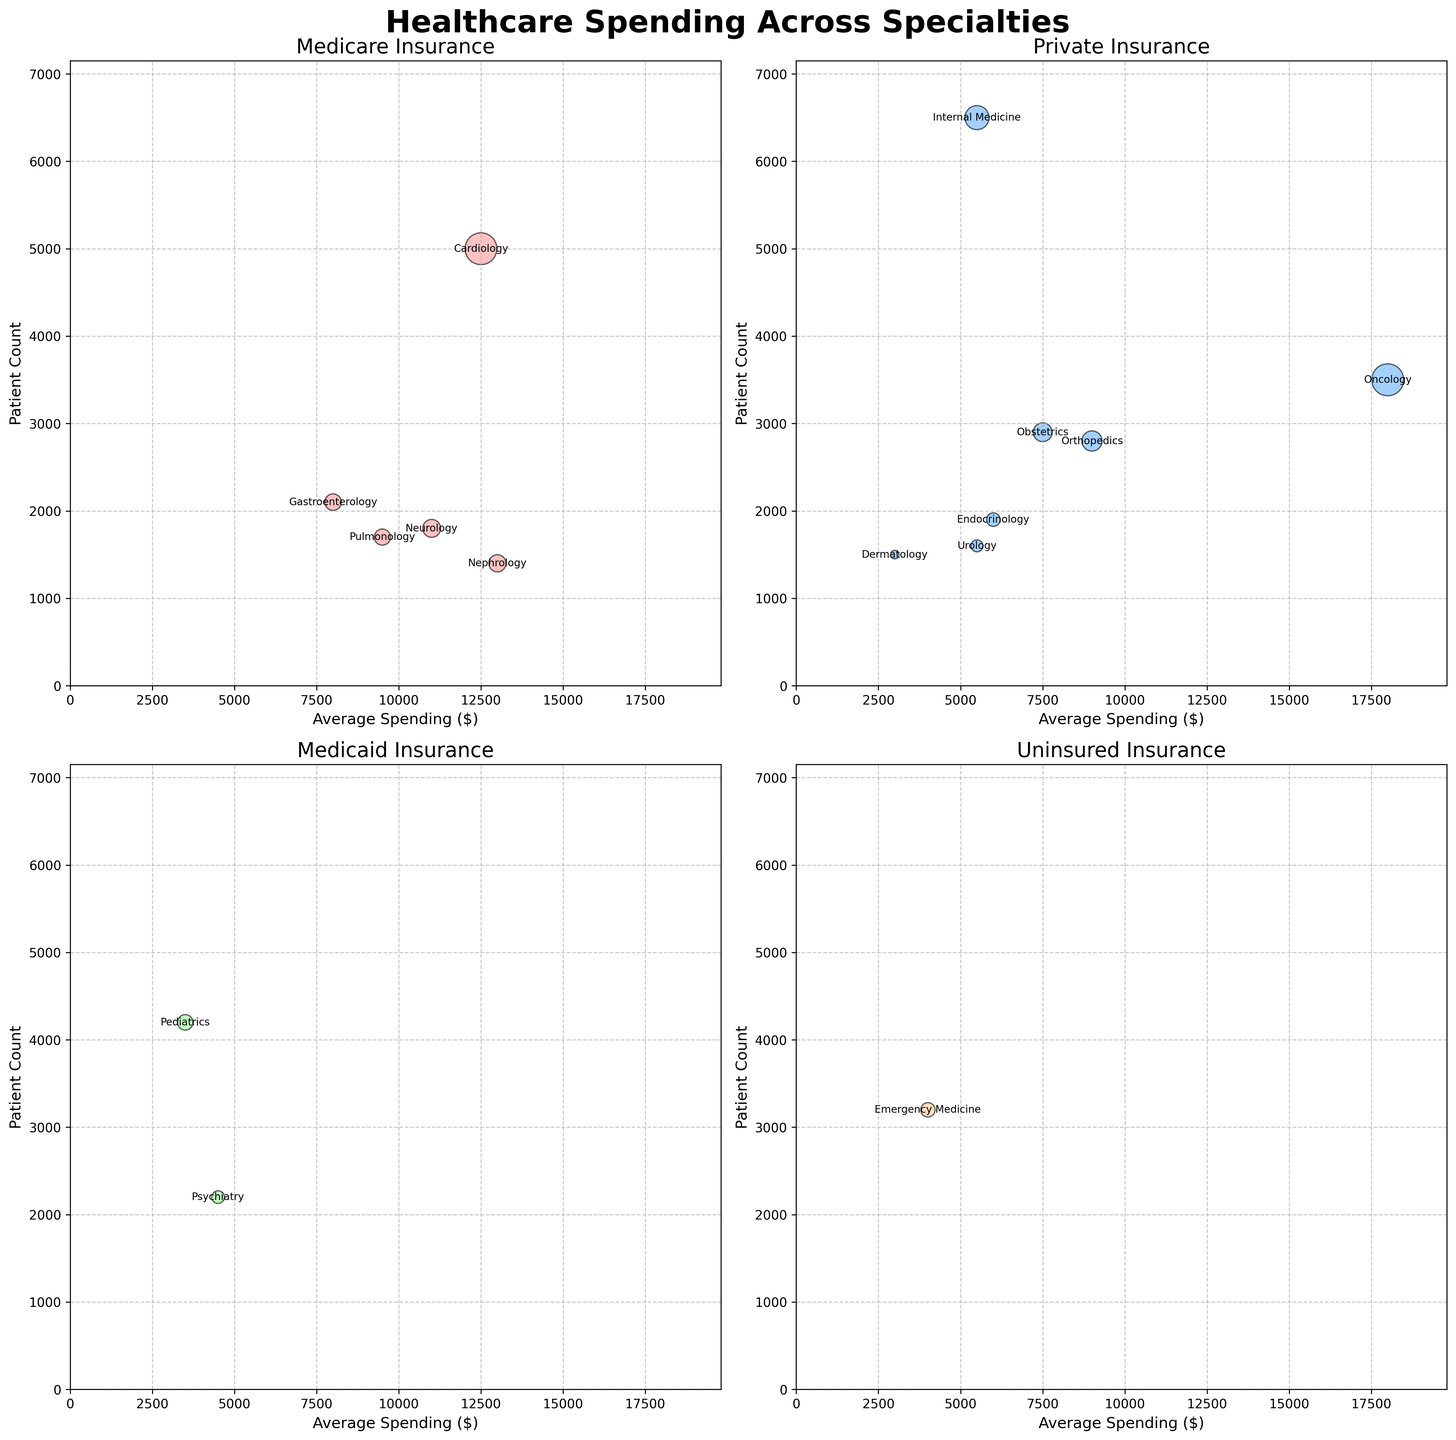What is the title of the figure? The title is displayed at the center top of the figure in large, bold font, which reads "Healthcare Spending Across Specialties"
Answer: Healthcare Spending Across Specialties What are the insurance types displayed in the figure? There are four subplots in the figure each titled with "Medicare", "Private", "Medicaid", and "Uninsured". These titles are visible at the top of each subplot.
Answer: Medicare, Private, Medicaid, Uninsured In which insurance type does Cardiology have the highest average spending? We need to locate the subplot titled "Medicare" and find the bubble with the annotation "Cardiology". Then, we check the x-axis value for that bubble, which represents the average spending.
Answer: Medicare Which specialty under Medicaid has the highest patient count? In the subplot titled "Medicaid", we identify the bubble with the highest y-axis value, representing the highest patient count. The annotation of that bubble indicates the specialty.
Answer: Pediatrics Compare the average spending of Oncology and Internal Medicine under Private insurance. Which one is higher and by approximately how much? Locate the subplot titled "Private" and find the bubbles for "Oncology" and "Internal Medicine". Compare their positions on the x-axis (average spending). Oncology is around 18000, and Internal Medicine is around 5500. The difference is approximately 12500.
Answer: Oncology by approximately 12500 Which specialty has the largest bubble in the "Uninsured" subplot and what does it signify? In the subplot titled "Uninsured", identify the bubble with the largest size. The size of the bubble is a function of average spending multiplied by patient count. The annotation inside or near this bubble shows the specialty.
Answer: Emergency Medicine Is there any specialty under Medicare that has a smaller patient count but higher average spending than Neurology? Find Neurology in the "Medicare" subplot, noting its y-axis value (patient count) and x-axis value (average spending). Then, look for any other bubble to the right (higher spending) but lower on the y-axis (smaller patient count).
Answer: Nephrology What is the general trend observed between average spending and patient count across all subplots? By observing the scatterplots in all four subplots, we can see if there is a discernible pattern, such as whether bubbles tend to be higher on the y-axis (more patients) as they move to the right on the x-axis (more spending) or vice versa.
Answer: No clear trend Which specialty and insurance category represent the lowest average spending visible in the figure? By scanning all four subplots and checking the x-axis positions, the lowest average spending bubble is identified. The annotation within or near the smallest x-axis value reveals the specialty and insurance type.
Answer: Dermatology under Private For Private insurance, calculate the sum of patient counts for Orthopedics, Obstetrics, and Endocrinology. Locate the bubbles for Orthopedics, Obstetrics, and Endocrinology in the "Private" subplot, and add their y-axis values (patient counts) together: 2800 (Orthopedics) + 2900 (Obstetrics) + 1900 (Endocrinology).
Answer: 7600 